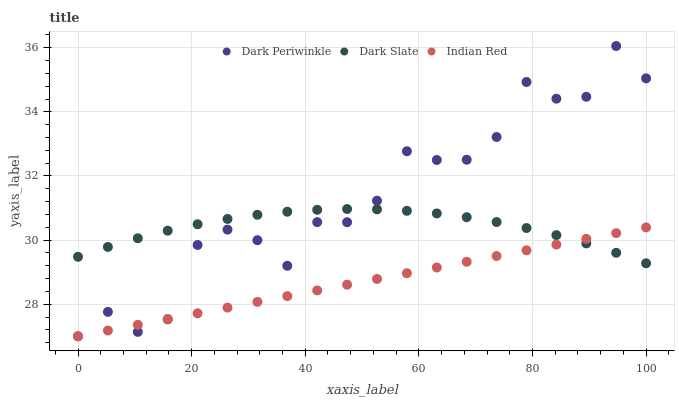Does Indian Red have the minimum area under the curve?
Answer yes or no. Yes. Does Dark Periwinkle have the maximum area under the curve?
Answer yes or no. Yes. Does Dark Periwinkle have the minimum area under the curve?
Answer yes or no. No. Does Indian Red have the maximum area under the curve?
Answer yes or no. No. Is Indian Red the smoothest?
Answer yes or no. Yes. Is Dark Periwinkle the roughest?
Answer yes or no. Yes. Is Dark Periwinkle the smoothest?
Answer yes or no. No. Is Indian Red the roughest?
Answer yes or no. No. Does Dark Periwinkle have the lowest value?
Answer yes or no. Yes. Does Dark Periwinkle have the highest value?
Answer yes or no. Yes. Does Indian Red have the highest value?
Answer yes or no. No. Does Dark Periwinkle intersect Indian Red?
Answer yes or no. Yes. Is Dark Periwinkle less than Indian Red?
Answer yes or no. No. Is Dark Periwinkle greater than Indian Red?
Answer yes or no. No. 